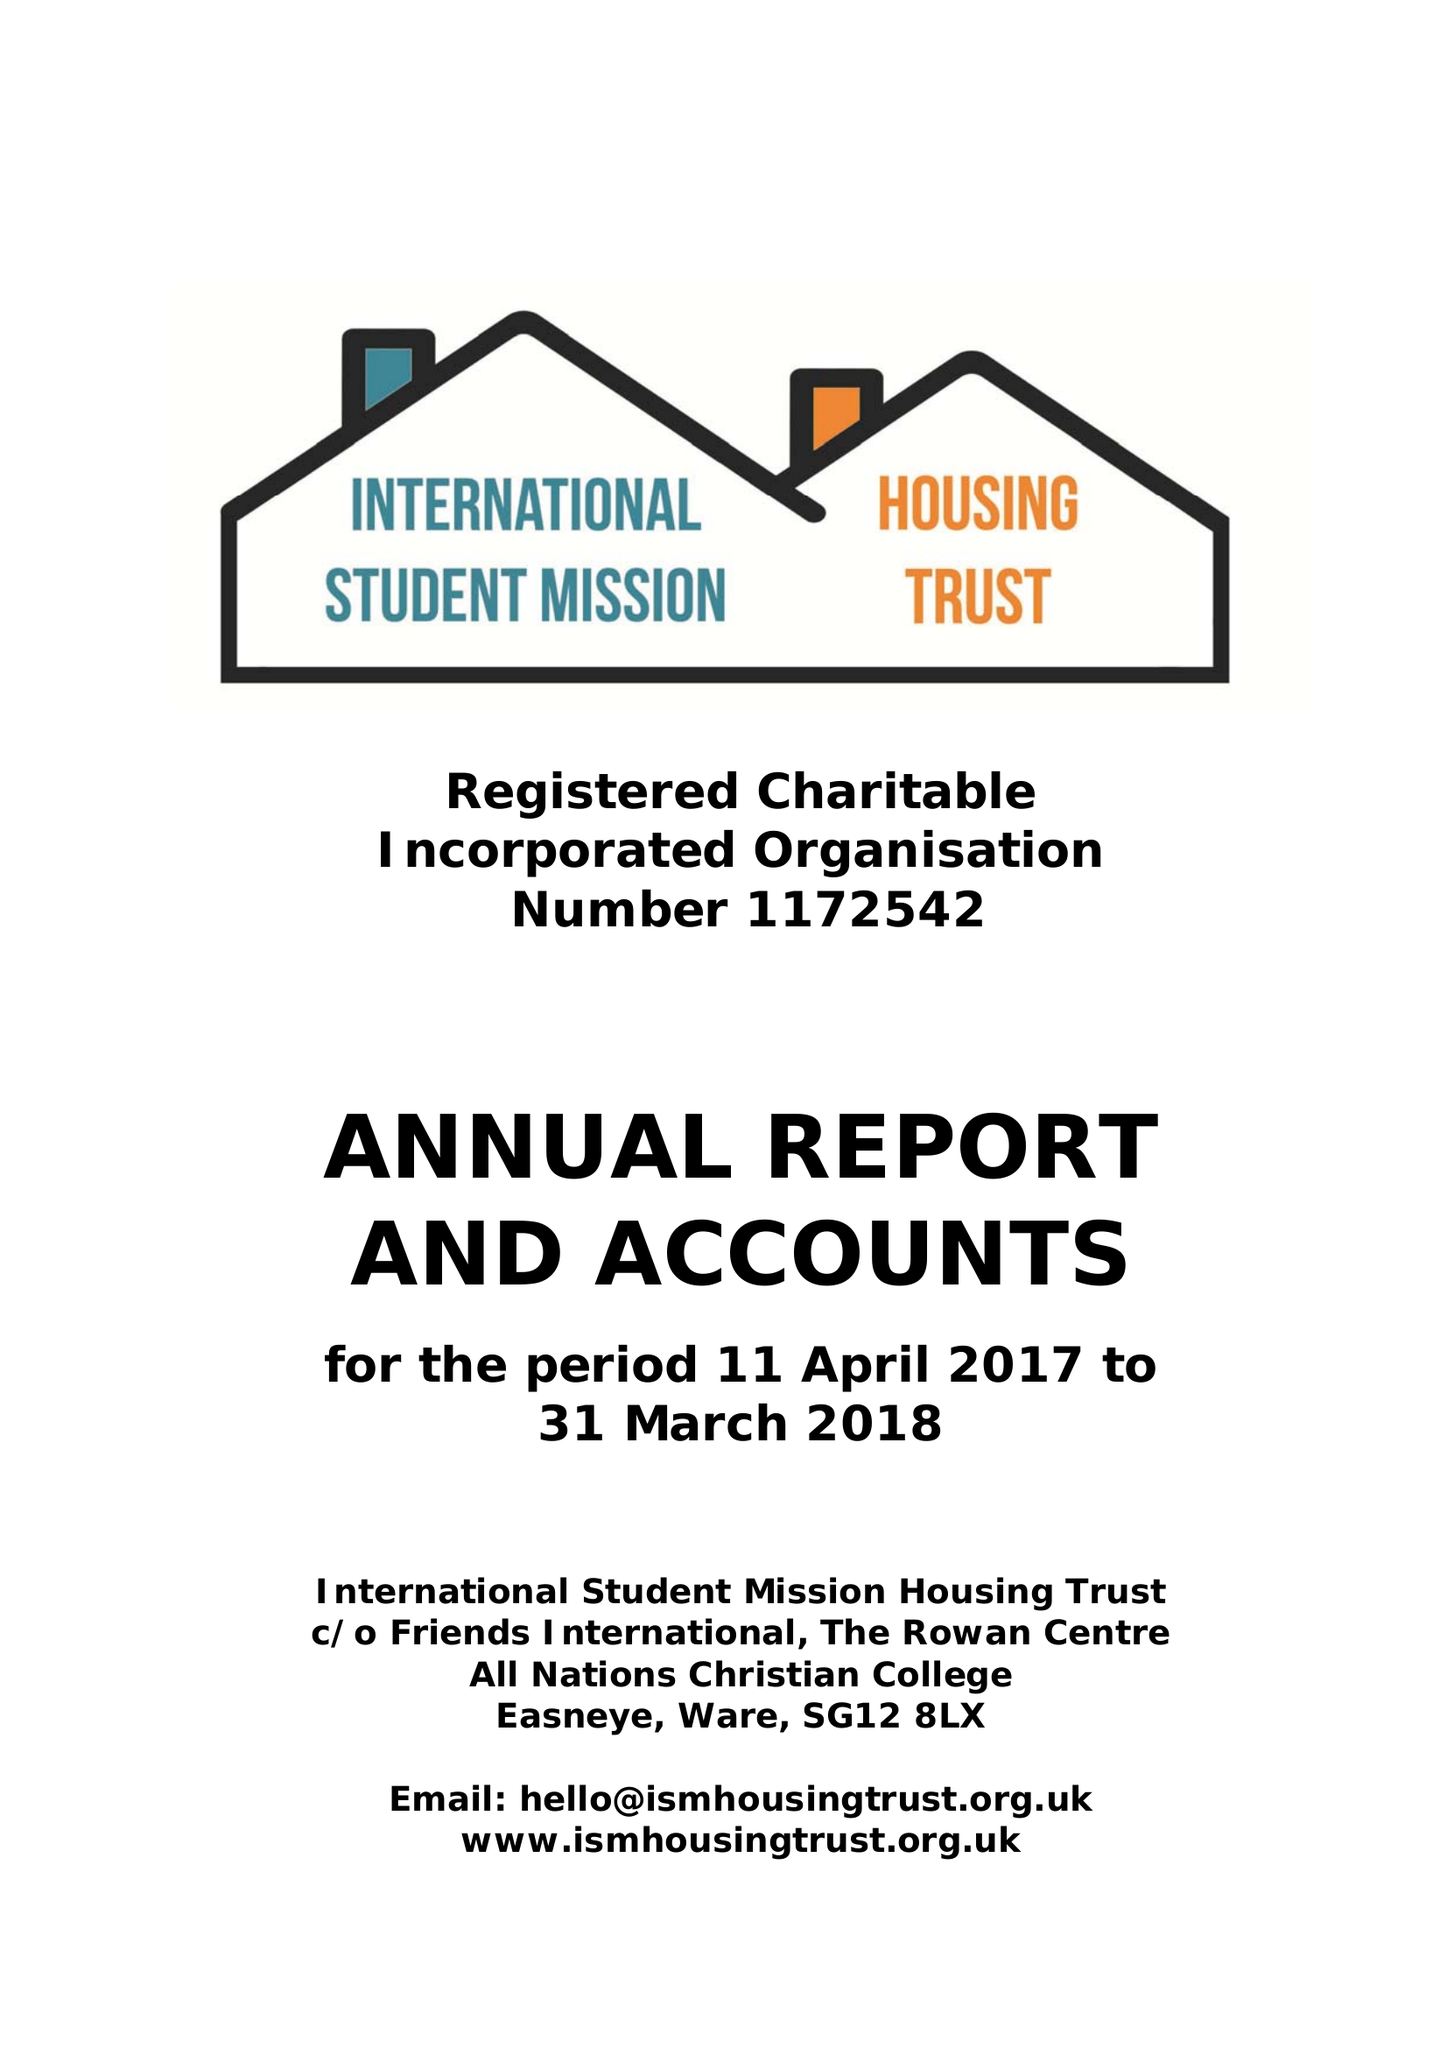What is the value for the charity_number?
Answer the question using a single word or phrase. 1172542 